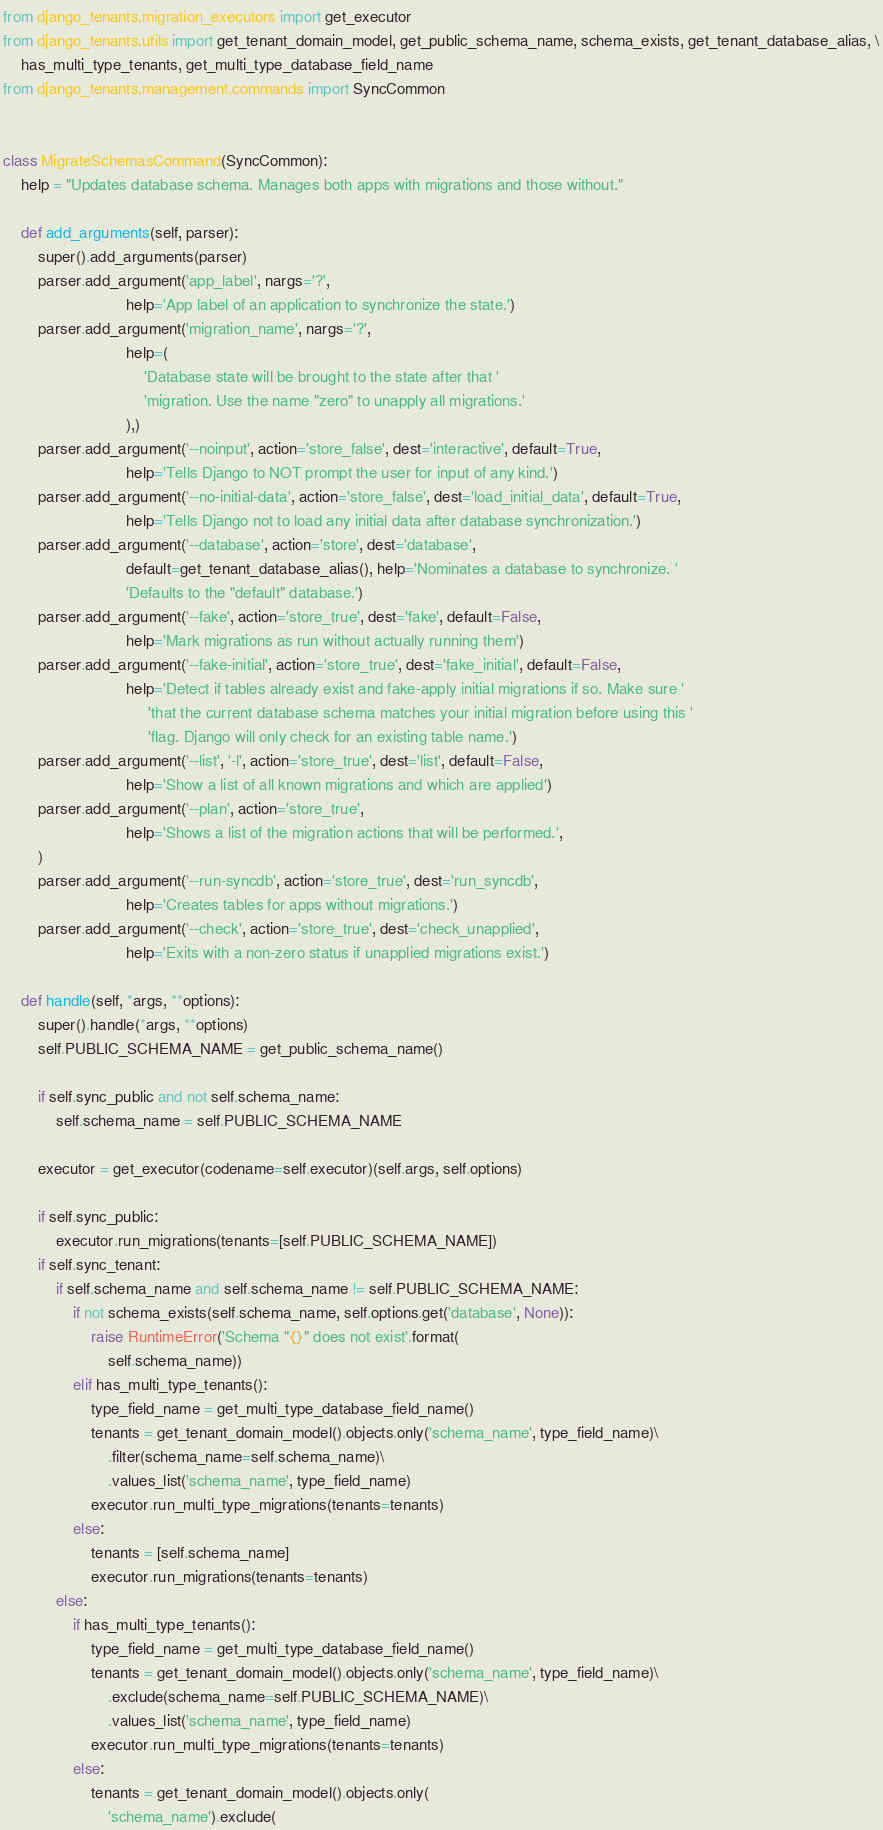<code> <loc_0><loc_0><loc_500><loc_500><_Python_>from django_tenants.migration_executors import get_executor
from django_tenants.utils import get_tenant_domain_model, get_public_schema_name, schema_exists, get_tenant_database_alias, \
    has_multi_type_tenants, get_multi_type_database_field_name
from django_tenants.management.commands import SyncCommon


class MigrateSchemasCommand(SyncCommon):
    help = "Updates database schema. Manages both apps with migrations and those without."

    def add_arguments(self, parser):
        super().add_arguments(parser)
        parser.add_argument('app_label', nargs='?',
                            help='App label of an application to synchronize the state.')
        parser.add_argument('migration_name', nargs='?',
                            help=(
                                'Database state will be brought to the state after that '
                                'migration. Use the name "zero" to unapply all migrations.'
                            ),)
        parser.add_argument('--noinput', action='store_false', dest='interactive', default=True,
                            help='Tells Django to NOT prompt the user for input of any kind.')
        parser.add_argument('--no-initial-data', action='store_false', dest='load_initial_data', default=True,
                            help='Tells Django not to load any initial data after database synchronization.')
        parser.add_argument('--database', action='store', dest='database',
                            default=get_tenant_database_alias(), help='Nominates a database to synchronize. '
                            'Defaults to the "default" database.')
        parser.add_argument('--fake', action='store_true', dest='fake', default=False,
                            help='Mark migrations as run without actually running them')
        parser.add_argument('--fake-initial', action='store_true', dest='fake_initial', default=False,
                            help='Detect if tables already exist and fake-apply initial migrations if so. Make sure '
                                 'that the current database schema matches your initial migration before using this '
                                 'flag. Django will only check for an existing table name.')
        parser.add_argument('--list', '-l', action='store_true', dest='list', default=False,
                            help='Show a list of all known migrations and which are applied')
        parser.add_argument('--plan', action='store_true',
                            help='Shows a list of the migration actions that will be performed.',
        )
        parser.add_argument('--run-syncdb', action='store_true', dest='run_syncdb',
                            help='Creates tables for apps without migrations.')
        parser.add_argument('--check', action='store_true', dest='check_unapplied',
                            help='Exits with a non-zero status if unapplied migrations exist.')

    def handle(self, *args, **options):
        super().handle(*args, **options)
        self.PUBLIC_SCHEMA_NAME = get_public_schema_name()

        if self.sync_public and not self.schema_name:
            self.schema_name = self.PUBLIC_SCHEMA_NAME

        executor = get_executor(codename=self.executor)(self.args, self.options)

        if self.sync_public:
            executor.run_migrations(tenants=[self.PUBLIC_SCHEMA_NAME])
        if self.sync_tenant:
            if self.schema_name and self.schema_name != self.PUBLIC_SCHEMA_NAME:
                if not schema_exists(self.schema_name, self.options.get('database', None)):
                    raise RuntimeError('Schema "{}" does not exist'.format(
                        self.schema_name))
                elif has_multi_type_tenants():
                    type_field_name = get_multi_type_database_field_name()
                    tenants = get_tenant_domain_model().objects.only('schema_name', type_field_name)\
                        .filter(schema_name=self.schema_name)\
                        .values_list('schema_name', type_field_name)
                    executor.run_multi_type_migrations(tenants=tenants)
                else:
                    tenants = [self.schema_name]
                    executor.run_migrations(tenants=tenants)
            else:
                if has_multi_type_tenants():
                    type_field_name = get_multi_type_database_field_name()
                    tenants = get_tenant_domain_model().objects.only('schema_name', type_field_name)\
                        .exclude(schema_name=self.PUBLIC_SCHEMA_NAME)\
                        .values_list('schema_name', type_field_name)
                    executor.run_multi_type_migrations(tenants=tenants)
                else:
                    tenants = get_tenant_domain_model().objects.only(
                        'schema_name').exclude(</code> 